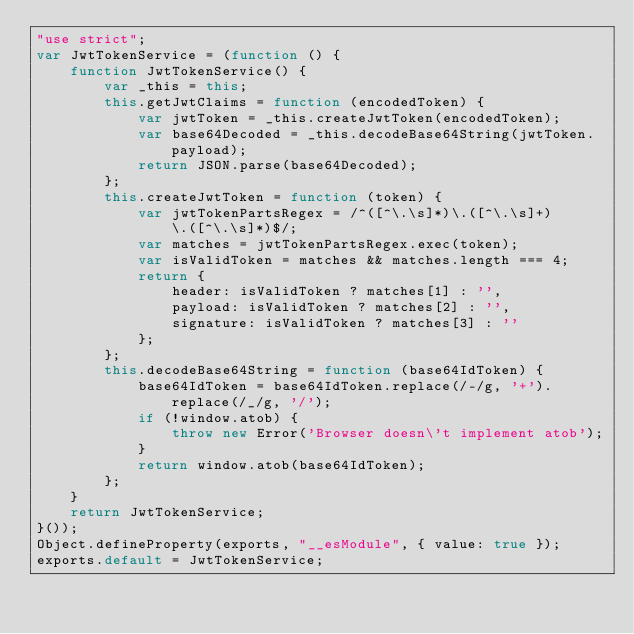Convert code to text. <code><loc_0><loc_0><loc_500><loc_500><_JavaScript_>"use strict";
var JwtTokenService = (function () {
    function JwtTokenService() {
        var _this = this;
        this.getJwtClaims = function (encodedToken) {
            var jwtToken = _this.createJwtToken(encodedToken);
            var base64Decoded = _this.decodeBase64String(jwtToken.payload);
            return JSON.parse(base64Decoded);
        };
        this.createJwtToken = function (token) {
            var jwtTokenPartsRegex = /^([^\.\s]*)\.([^\.\s]+)\.([^\.\s]*)$/;
            var matches = jwtTokenPartsRegex.exec(token);
            var isValidToken = matches && matches.length === 4;
            return {
                header: isValidToken ? matches[1] : '',
                payload: isValidToken ? matches[2] : '',
                signature: isValidToken ? matches[3] : ''
            };
        };
        this.decodeBase64String = function (base64IdToken) {
            base64IdToken = base64IdToken.replace(/-/g, '+').replace(/_/g, '/');
            if (!window.atob) {
                throw new Error('Browser doesn\'t implement atob');
            }
            return window.atob(base64IdToken);
        };
    }
    return JwtTokenService;
}());
Object.defineProperty(exports, "__esModule", { value: true });
exports.default = JwtTokenService;
</code> 